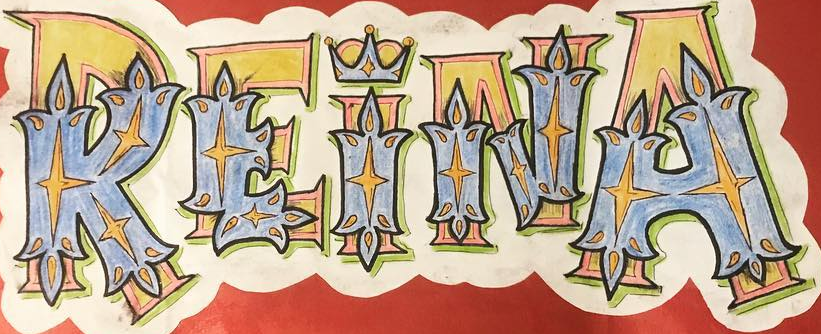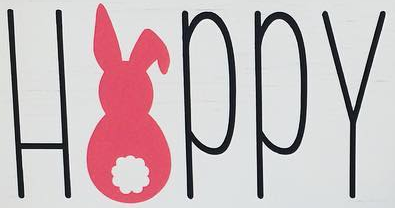Identify the words shown in these images in order, separated by a semicolon. REINA; HAPPY 